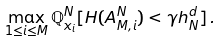Convert formula to latex. <formula><loc_0><loc_0><loc_500><loc_500>\max _ { 1 \leq i \leq M } \mathbb { Q } ^ { N } _ { x _ { i } } [ H ( A ^ { N } _ { M , i } ) < \gamma h ^ { d } _ { N } ] \, .</formula> 